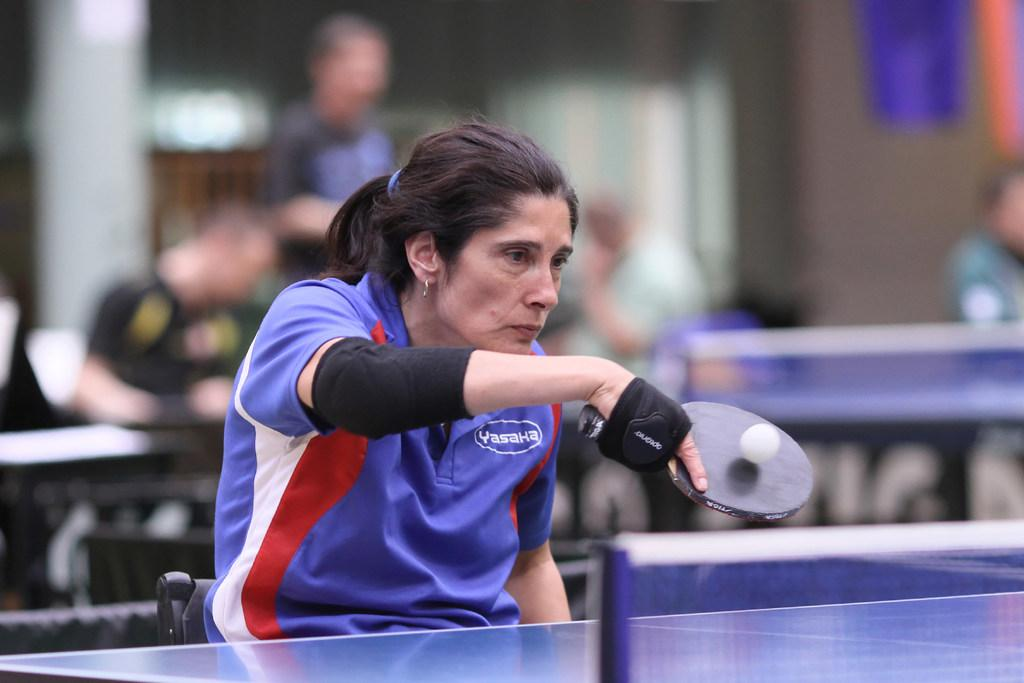Who is the main subject in the image? There is a woman in the image. What is the woman holding in the image? The woman is holding a racket. What activity is the woman engaged in? The woman is playing with a ball. What other objects are present in the image? There is a board and a net in the image. How does the maid clean the board in the image? There is no maid present in the image, and the board is not being cleaned. 